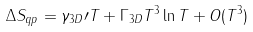<formula> <loc_0><loc_0><loc_500><loc_500>\Delta S _ { q p } = \gamma _ { 3 D } \prime T + \Gamma _ { 3 D } T ^ { 3 } \ln T + O ( { T ^ { 3 } } )</formula> 